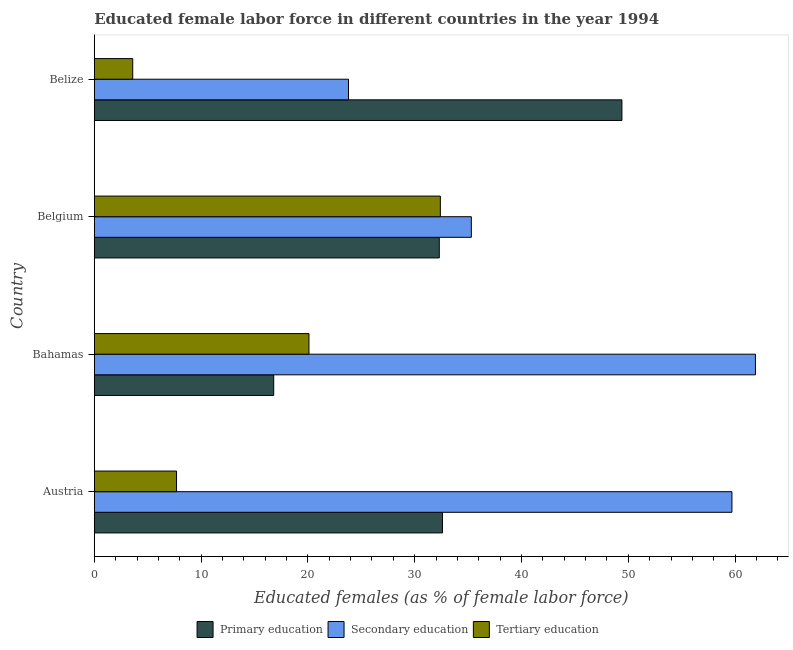How many different coloured bars are there?
Give a very brief answer. 3. How many groups of bars are there?
Keep it short and to the point. 4. Are the number of bars per tick equal to the number of legend labels?
Make the answer very short. Yes. Are the number of bars on each tick of the Y-axis equal?
Offer a terse response. Yes. In how many cases, is the number of bars for a given country not equal to the number of legend labels?
Keep it short and to the point. 0. What is the percentage of female labor force who received tertiary education in Bahamas?
Your answer should be very brief. 20.1. Across all countries, what is the maximum percentage of female labor force who received primary education?
Offer a terse response. 49.4. Across all countries, what is the minimum percentage of female labor force who received primary education?
Make the answer very short. 16.8. In which country was the percentage of female labor force who received tertiary education minimum?
Offer a very short reply. Belize. What is the total percentage of female labor force who received secondary education in the graph?
Offer a terse response. 180.7. What is the difference between the percentage of female labor force who received secondary education in Austria and that in Belize?
Provide a short and direct response. 35.9. What is the difference between the percentage of female labor force who received secondary education in Belgium and the percentage of female labor force who received primary education in Bahamas?
Your response must be concise. 18.5. What is the average percentage of female labor force who received tertiary education per country?
Offer a terse response. 15.95. What is the difference between the percentage of female labor force who received tertiary education and percentage of female labor force who received secondary education in Belize?
Provide a succinct answer. -20.2. What is the ratio of the percentage of female labor force who received tertiary education in Bahamas to that in Belgium?
Offer a terse response. 0.62. Is the percentage of female labor force who received tertiary education in Austria less than that in Belize?
Your answer should be very brief. No. Is the difference between the percentage of female labor force who received secondary education in Bahamas and Belize greater than the difference between the percentage of female labor force who received primary education in Bahamas and Belize?
Offer a terse response. Yes. What is the difference between the highest and the lowest percentage of female labor force who received secondary education?
Your response must be concise. 38.1. What does the 2nd bar from the top in Belgium represents?
Offer a terse response. Secondary education. What does the 2nd bar from the bottom in Austria represents?
Your answer should be compact. Secondary education. How many countries are there in the graph?
Ensure brevity in your answer.  4. Does the graph contain grids?
Offer a very short reply. No. Where does the legend appear in the graph?
Your answer should be very brief. Bottom center. How are the legend labels stacked?
Make the answer very short. Horizontal. What is the title of the graph?
Give a very brief answer. Educated female labor force in different countries in the year 1994. Does "Hydroelectric sources" appear as one of the legend labels in the graph?
Your response must be concise. No. What is the label or title of the X-axis?
Your answer should be very brief. Educated females (as % of female labor force). What is the Educated females (as % of female labor force) of Primary education in Austria?
Your answer should be compact. 32.6. What is the Educated females (as % of female labor force) of Secondary education in Austria?
Give a very brief answer. 59.7. What is the Educated females (as % of female labor force) in Tertiary education in Austria?
Keep it short and to the point. 7.7. What is the Educated females (as % of female labor force) in Primary education in Bahamas?
Keep it short and to the point. 16.8. What is the Educated females (as % of female labor force) of Secondary education in Bahamas?
Offer a terse response. 61.9. What is the Educated females (as % of female labor force) of Tertiary education in Bahamas?
Provide a succinct answer. 20.1. What is the Educated females (as % of female labor force) of Primary education in Belgium?
Offer a terse response. 32.3. What is the Educated females (as % of female labor force) in Secondary education in Belgium?
Offer a terse response. 35.3. What is the Educated females (as % of female labor force) of Tertiary education in Belgium?
Provide a short and direct response. 32.4. What is the Educated females (as % of female labor force) of Primary education in Belize?
Ensure brevity in your answer.  49.4. What is the Educated females (as % of female labor force) of Secondary education in Belize?
Provide a short and direct response. 23.8. What is the Educated females (as % of female labor force) in Tertiary education in Belize?
Ensure brevity in your answer.  3.6. Across all countries, what is the maximum Educated females (as % of female labor force) of Primary education?
Provide a short and direct response. 49.4. Across all countries, what is the maximum Educated females (as % of female labor force) in Secondary education?
Ensure brevity in your answer.  61.9. Across all countries, what is the maximum Educated females (as % of female labor force) in Tertiary education?
Your answer should be very brief. 32.4. Across all countries, what is the minimum Educated females (as % of female labor force) in Primary education?
Your answer should be very brief. 16.8. Across all countries, what is the minimum Educated females (as % of female labor force) in Secondary education?
Offer a very short reply. 23.8. Across all countries, what is the minimum Educated females (as % of female labor force) in Tertiary education?
Provide a short and direct response. 3.6. What is the total Educated females (as % of female labor force) of Primary education in the graph?
Make the answer very short. 131.1. What is the total Educated females (as % of female labor force) of Secondary education in the graph?
Ensure brevity in your answer.  180.7. What is the total Educated females (as % of female labor force) in Tertiary education in the graph?
Give a very brief answer. 63.8. What is the difference between the Educated females (as % of female labor force) of Primary education in Austria and that in Belgium?
Keep it short and to the point. 0.3. What is the difference between the Educated females (as % of female labor force) in Secondary education in Austria and that in Belgium?
Make the answer very short. 24.4. What is the difference between the Educated females (as % of female labor force) of Tertiary education in Austria and that in Belgium?
Offer a terse response. -24.7. What is the difference between the Educated females (as % of female labor force) in Primary education in Austria and that in Belize?
Ensure brevity in your answer.  -16.8. What is the difference between the Educated females (as % of female labor force) in Secondary education in Austria and that in Belize?
Give a very brief answer. 35.9. What is the difference between the Educated females (as % of female labor force) of Primary education in Bahamas and that in Belgium?
Your response must be concise. -15.5. What is the difference between the Educated females (as % of female labor force) in Secondary education in Bahamas and that in Belgium?
Your answer should be compact. 26.6. What is the difference between the Educated females (as % of female labor force) in Primary education in Bahamas and that in Belize?
Offer a terse response. -32.6. What is the difference between the Educated females (as % of female labor force) of Secondary education in Bahamas and that in Belize?
Keep it short and to the point. 38.1. What is the difference between the Educated females (as % of female labor force) in Primary education in Belgium and that in Belize?
Provide a short and direct response. -17.1. What is the difference between the Educated females (as % of female labor force) of Secondary education in Belgium and that in Belize?
Provide a succinct answer. 11.5. What is the difference between the Educated females (as % of female labor force) of Tertiary education in Belgium and that in Belize?
Your answer should be very brief. 28.8. What is the difference between the Educated females (as % of female labor force) in Primary education in Austria and the Educated females (as % of female labor force) in Secondary education in Bahamas?
Offer a very short reply. -29.3. What is the difference between the Educated females (as % of female labor force) in Primary education in Austria and the Educated females (as % of female labor force) in Tertiary education in Bahamas?
Make the answer very short. 12.5. What is the difference between the Educated females (as % of female labor force) of Secondary education in Austria and the Educated females (as % of female labor force) of Tertiary education in Bahamas?
Give a very brief answer. 39.6. What is the difference between the Educated females (as % of female labor force) in Secondary education in Austria and the Educated females (as % of female labor force) in Tertiary education in Belgium?
Your response must be concise. 27.3. What is the difference between the Educated females (as % of female labor force) of Primary education in Austria and the Educated females (as % of female labor force) of Secondary education in Belize?
Your answer should be compact. 8.8. What is the difference between the Educated females (as % of female labor force) in Primary education in Austria and the Educated females (as % of female labor force) in Tertiary education in Belize?
Your response must be concise. 29. What is the difference between the Educated females (as % of female labor force) of Secondary education in Austria and the Educated females (as % of female labor force) of Tertiary education in Belize?
Your answer should be compact. 56.1. What is the difference between the Educated females (as % of female labor force) of Primary education in Bahamas and the Educated females (as % of female labor force) of Secondary education in Belgium?
Give a very brief answer. -18.5. What is the difference between the Educated females (as % of female labor force) of Primary education in Bahamas and the Educated females (as % of female labor force) of Tertiary education in Belgium?
Provide a succinct answer. -15.6. What is the difference between the Educated females (as % of female labor force) of Secondary education in Bahamas and the Educated females (as % of female labor force) of Tertiary education in Belgium?
Make the answer very short. 29.5. What is the difference between the Educated females (as % of female labor force) of Secondary education in Bahamas and the Educated females (as % of female labor force) of Tertiary education in Belize?
Provide a short and direct response. 58.3. What is the difference between the Educated females (as % of female labor force) of Primary education in Belgium and the Educated females (as % of female labor force) of Tertiary education in Belize?
Make the answer very short. 28.7. What is the difference between the Educated females (as % of female labor force) in Secondary education in Belgium and the Educated females (as % of female labor force) in Tertiary education in Belize?
Make the answer very short. 31.7. What is the average Educated females (as % of female labor force) in Primary education per country?
Provide a short and direct response. 32.77. What is the average Educated females (as % of female labor force) in Secondary education per country?
Provide a succinct answer. 45.17. What is the average Educated females (as % of female labor force) of Tertiary education per country?
Your answer should be compact. 15.95. What is the difference between the Educated females (as % of female labor force) in Primary education and Educated females (as % of female labor force) in Secondary education in Austria?
Provide a short and direct response. -27.1. What is the difference between the Educated females (as % of female labor force) of Primary education and Educated females (as % of female labor force) of Tertiary education in Austria?
Make the answer very short. 24.9. What is the difference between the Educated females (as % of female labor force) in Secondary education and Educated females (as % of female labor force) in Tertiary education in Austria?
Provide a succinct answer. 52. What is the difference between the Educated females (as % of female labor force) in Primary education and Educated females (as % of female labor force) in Secondary education in Bahamas?
Offer a terse response. -45.1. What is the difference between the Educated females (as % of female labor force) in Secondary education and Educated females (as % of female labor force) in Tertiary education in Bahamas?
Provide a short and direct response. 41.8. What is the difference between the Educated females (as % of female labor force) of Primary education and Educated females (as % of female labor force) of Secondary education in Belgium?
Give a very brief answer. -3. What is the difference between the Educated females (as % of female labor force) of Primary education and Educated females (as % of female labor force) of Secondary education in Belize?
Provide a short and direct response. 25.6. What is the difference between the Educated females (as % of female labor force) in Primary education and Educated females (as % of female labor force) in Tertiary education in Belize?
Provide a succinct answer. 45.8. What is the difference between the Educated females (as % of female labor force) of Secondary education and Educated females (as % of female labor force) of Tertiary education in Belize?
Make the answer very short. 20.2. What is the ratio of the Educated females (as % of female labor force) in Primary education in Austria to that in Bahamas?
Make the answer very short. 1.94. What is the ratio of the Educated females (as % of female labor force) in Secondary education in Austria to that in Bahamas?
Provide a short and direct response. 0.96. What is the ratio of the Educated females (as % of female labor force) in Tertiary education in Austria to that in Bahamas?
Your answer should be compact. 0.38. What is the ratio of the Educated females (as % of female labor force) in Primary education in Austria to that in Belgium?
Your response must be concise. 1.01. What is the ratio of the Educated females (as % of female labor force) in Secondary education in Austria to that in Belgium?
Ensure brevity in your answer.  1.69. What is the ratio of the Educated females (as % of female labor force) in Tertiary education in Austria to that in Belgium?
Ensure brevity in your answer.  0.24. What is the ratio of the Educated females (as % of female labor force) in Primary education in Austria to that in Belize?
Provide a short and direct response. 0.66. What is the ratio of the Educated females (as % of female labor force) in Secondary education in Austria to that in Belize?
Offer a terse response. 2.51. What is the ratio of the Educated females (as % of female labor force) in Tertiary education in Austria to that in Belize?
Your answer should be very brief. 2.14. What is the ratio of the Educated females (as % of female labor force) in Primary education in Bahamas to that in Belgium?
Your response must be concise. 0.52. What is the ratio of the Educated females (as % of female labor force) of Secondary education in Bahamas to that in Belgium?
Ensure brevity in your answer.  1.75. What is the ratio of the Educated females (as % of female labor force) in Tertiary education in Bahamas to that in Belgium?
Offer a very short reply. 0.62. What is the ratio of the Educated females (as % of female labor force) in Primary education in Bahamas to that in Belize?
Ensure brevity in your answer.  0.34. What is the ratio of the Educated females (as % of female labor force) of Secondary education in Bahamas to that in Belize?
Your response must be concise. 2.6. What is the ratio of the Educated females (as % of female labor force) in Tertiary education in Bahamas to that in Belize?
Offer a very short reply. 5.58. What is the ratio of the Educated females (as % of female labor force) of Primary education in Belgium to that in Belize?
Your answer should be compact. 0.65. What is the ratio of the Educated females (as % of female labor force) of Secondary education in Belgium to that in Belize?
Keep it short and to the point. 1.48. What is the ratio of the Educated females (as % of female labor force) of Tertiary education in Belgium to that in Belize?
Ensure brevity in your answer.  9. What is the difference between the highest and the second highest Educated females (as % of female labor force) in Secondary education?
Make the answer very short. 2.2. What is the difference between the highest and the second highest Educated females (as % of female labor force) in Tertiary education?
Keep it short and to the point. 12.3. What is the difference between the highest and the lowest Educated females (as % of female labor force) of Primary education?
Ensure brevity in your answer.  32.6. What is the difference between the highest and the lowest Educated females (as % of female labor force) in Secondary education?
Provide a succinct answer. 38.1. What is the difference between the highest and the lowest Educated females (as % of female labor force) in Tertiary education?
Keep it short and to the point. 28.8. 